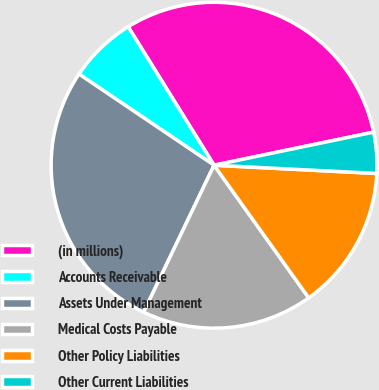Convert chart. <chart><loc_0><loc_0><loc_500><loc_500><pie_chart><fcel>(in millions)<fcel>Accounts Receivable<fcel>Assets Under Management<fcel>Medical Costs Payable<fcel>Other Policy Liabilities<fcel>Other Current Liabilities<nl><fcel>30.59%<fcel>6.71%<fcel>27.34%<fcel>16.98%<fcel>14.33%<fcel>4.06%<nl></chart> 